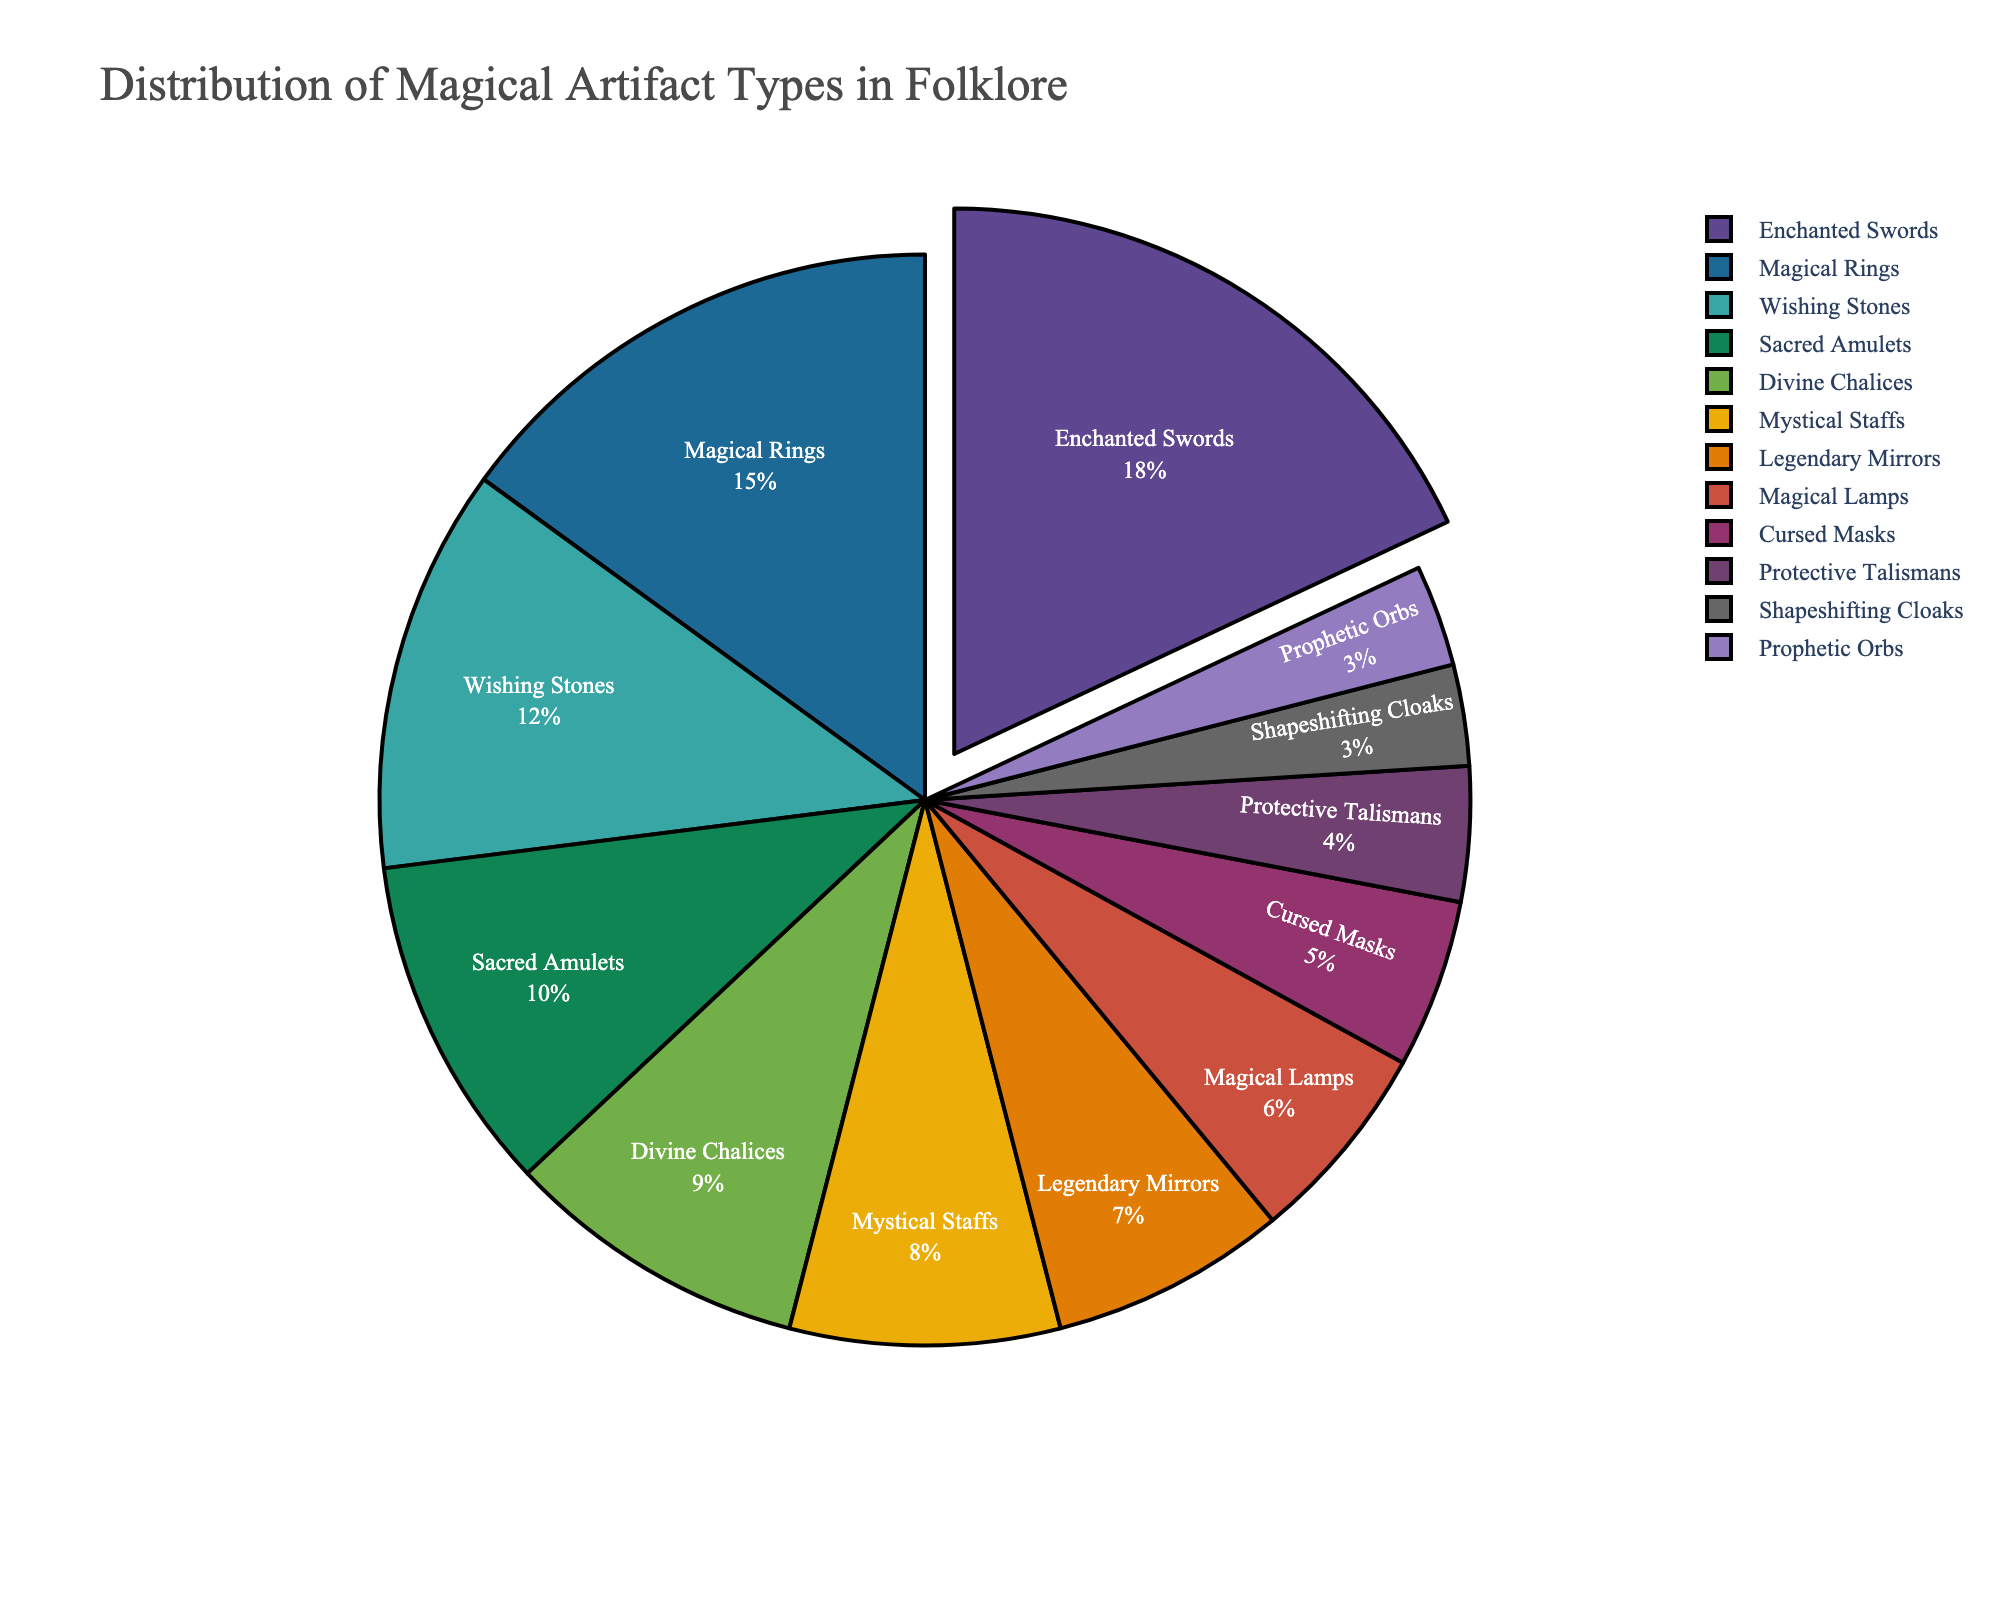What type of artifact is most common in the folklore distribution? The pie chart shows the distribution of different magical artifact types. The largest slice corresponds to "Enchanted Swords" with 18%.
Answer: Enchanted Swords Which artifact type has the smallest percentage? From the pie chart, the smallest slice indicates "Prophetic Orbs" and "Shapeshifting Cloaks," each with 3%.
Answer: Prophetic Orbs and Shapeshifting Cloaks Compare the percentages of "Sacred Amulets" and "Mystical Staffs" artifacts. The pie chart shows "Sacred Amulets" at 10% and "Mystical Staffs" at 8%. By comparing these values, "Sacred Amulets" have a higher percentage.
Answer: Sacred Amulets (10%) > Mystical Staffs (8%) Sum the percentages of "Magical Lamps," "Cursed Masks," and "Protective Talismans" artifacts. According to the pie chart: "Magical Lamps" is 6%, "Cursed Masks" is 5%, and "Protective Talismans" is 4%. Adding these up: 6% + 5% + 4% = 15%.
Answer: 15% What is the combined percentage of artifacts starting with the letter 'M'? Artifacts starting with 'M' are "Magical Rings" (15%), "Mystical Staffs" (8%), and "Magical Lamps" (6%). Summing these: 15% + 8% + 6% = 29%.
Answer: 29% How many artifact types have a percentage greater than or equal to 10%? By examining the pie chart slices, "Enchanted Swords" (18%), "Magical Rings" (15%), "Wishing Stones" (12%), and "Sacred Amulets" (10%) all meet the criteria. There are 4 such artifact types.
Answer: 4 What color is used to represent "Divine Chalices"? By observing the pie chart, each slice is color-coded, and the slice representing "Divine Chalices" is visually discernible. The exact color needs to be determined by viewing the chart, but typically represented in distinctive colors from the palette.
Answer: Needs visual confirmation from chart 